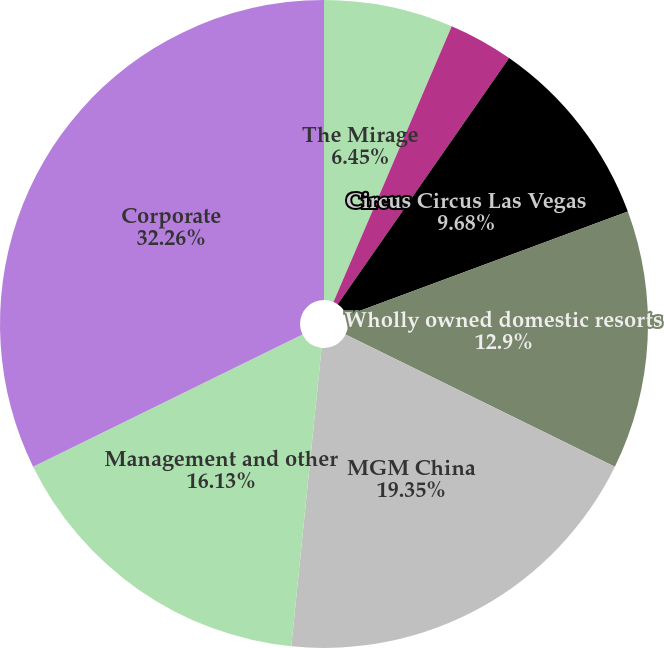Convert chart to OTSL. <chart><loc_0><loc_0><loc_500><loc_500><pie_chart><fcel>The Mirage<fcel>Luxor<fcel>New York-New York<fcel>Circus Circus Las Vegas<fcel>Wholly owned domestic resorts<fcel>MGM China<fcel>Management and other<fcel>Corporate<nl><fcel>6.45%<fcel>0.0%<fcel>3.23%<fcel>9.68%<fcel>12.9%<fcel>19.35%<fcel>16.13%<fcel>32.26%<nl></chart> 